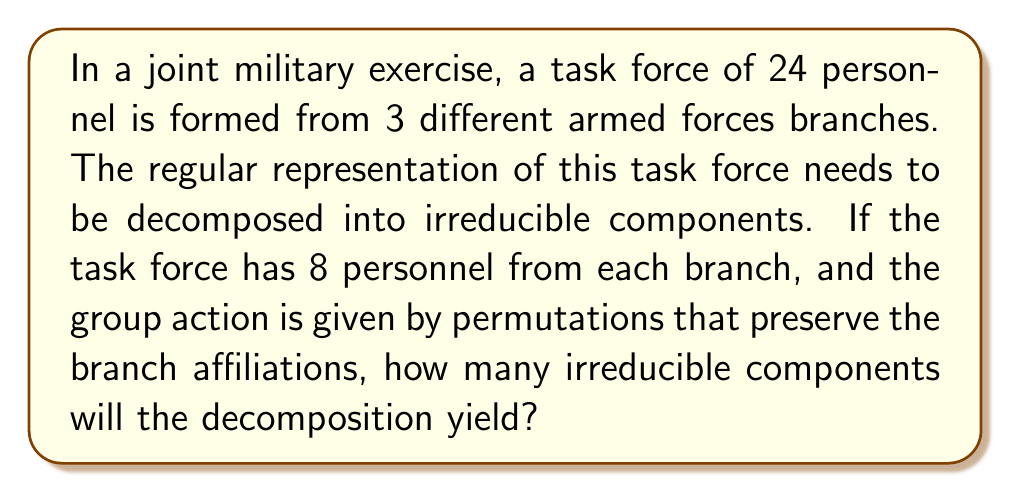What is the answer to this math problem? Let's approach this step-by-step:

1) The group in question is $S_8 \times S_8 \times S_8$, where each $S_8$ represents the permutations within each branch.

2) The regular representation of a group $G$ is isomorphic to the group algebra $\mathbb{C}[G]$. Its dimension is equal to the order of the group.

3) The order of our group is $|S_8 \times S_8 \times S_8| = (8!)^3$.

4) By the fundamental theorem of representation theory, the number of irreducible components is equal to the number of conjugacy classes of the group.

5) For $S_8 \times S_8 \times S_8$, the conjugacy classes are formed by independent conjugacy classes in each $S_8$.

6) The number of conjugacy classes in $S_n$ is equal to the number of partitions of $n$.

7) The number of partitions of 8 is 22.

8) Therefore, the number of conjugacy classes in $S_8 \times S_8 \times S_8$ is $22^3 = 10648$.

Thus, the regular representation will decompose into 10648 irreducible components.
Answer: 10648 